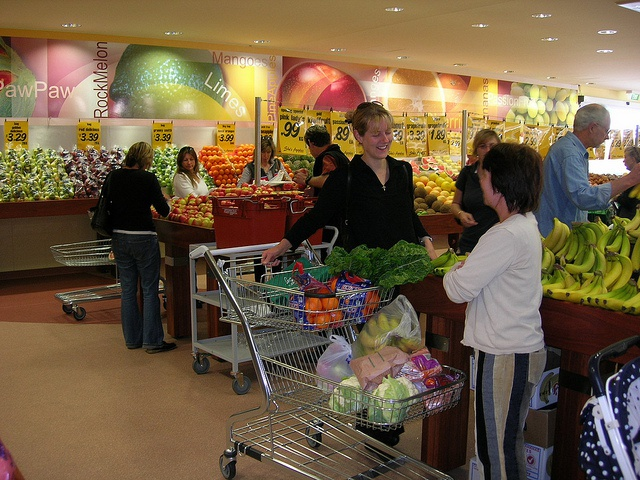Describe the objects in this image and their specific colors. I can see people in olive, darkgray, black, and gray tones, people in olive, black, maroon, and brown tones, people in olive, black, maroon, and gray tones, people in olive, gray, navy, and darkblue tones, and broccoli in olive, black, darkgreen, and gray tones in this image. 